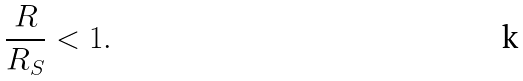Convert formula to latex. <formula><loc_0><loc_0><loc_500><loc_500>\frac { R } { R _ { S } } < 1 .</formula> 